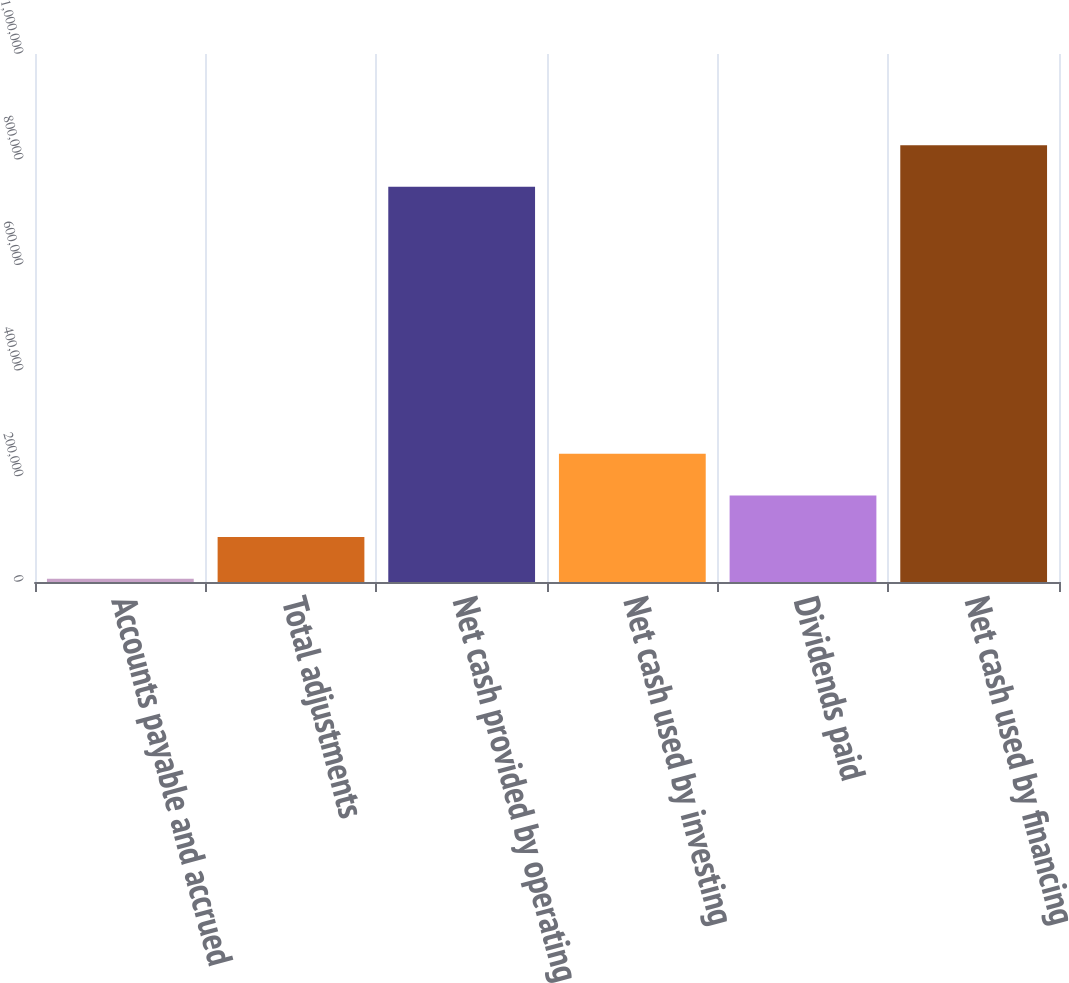Convert chart to OTSL. <chart><loc_0><loc_0><loc_500><loc_500><bar_chart><fcel>Accounts payable and accrued<fcel>Total adjustments<fcel>Net cash provided by operating<fcel>Net cash used by investing<fcel>Dividends paid<fcel>Net cash used by financing<nl><fcel>6368<fcel>85158.7<fcel>748488<fcel>242740<fcel>163949<fcel>827279<nl></chart> 